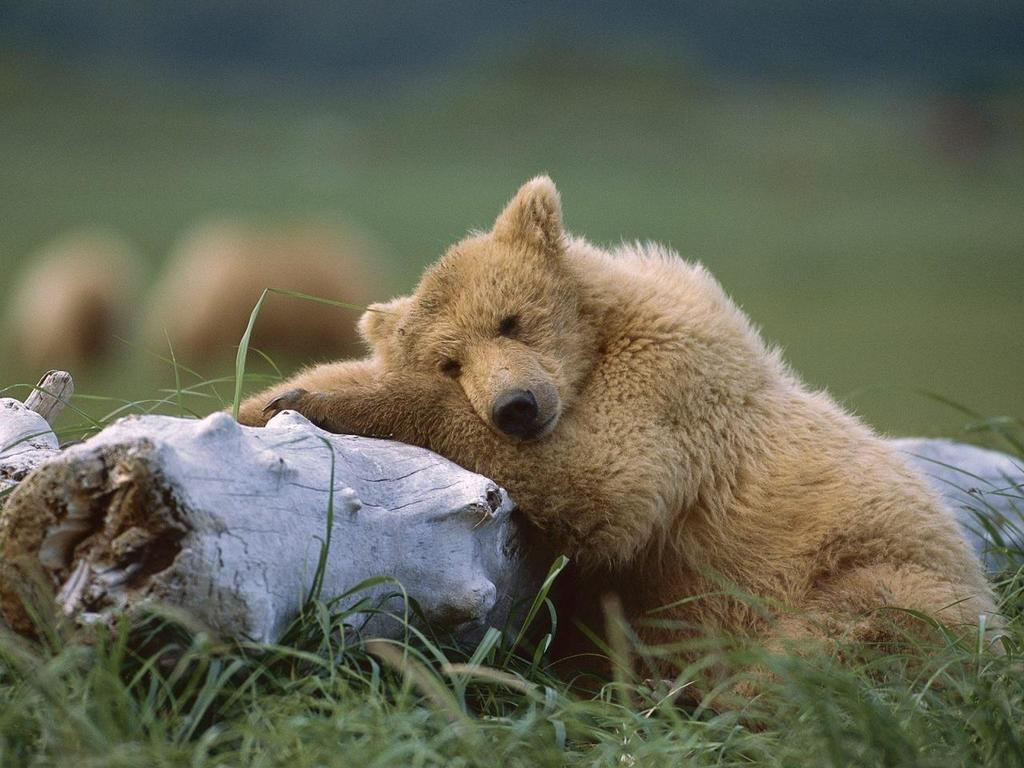What animal can be seen in the image? There is a bear in the image. What is the color of the bear? The bear is pale brown in color. What is the bear resting on? The bear is resting on a wooden log. What type of vegetation is visible in the image? There is grass visible in the image. How would you describe the background of the image? The background of the image is blurred. How many teeth can be seen in the bear's mouth in the image? There is no visible bear's mouth in the image, so it is not possible to determine the number of teeth. 